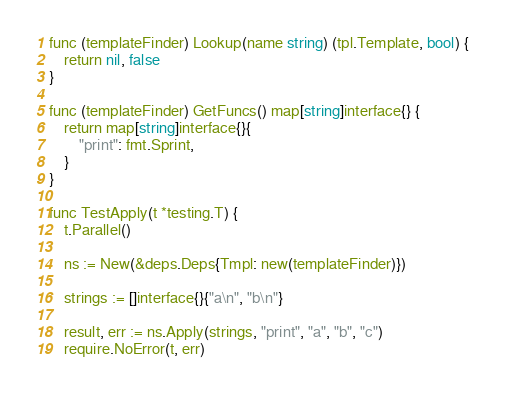<code> <loc_0><loc_0><loc_500><loc_500><_Go_>
func (templateFinder) Lookup(name string) (tpl.Template, bool) {
	return nil, false
}

func (templateFinder) GetFuncs() map[string]interface{} {
	return map[string]interface{}{
		"print": fmt.Sprint,
	}
}

func TestApply(t *testing.T) {
	t.Parallel()

	ns := New(&deps.Deps{Tmpl: new(templateFinder)})

	strings := []interface{}{"a\n", "b\n"}

	result, err := ns.Apply(strings, "print", "a", "b", "c")
	require.NoError(t, err)</code> 